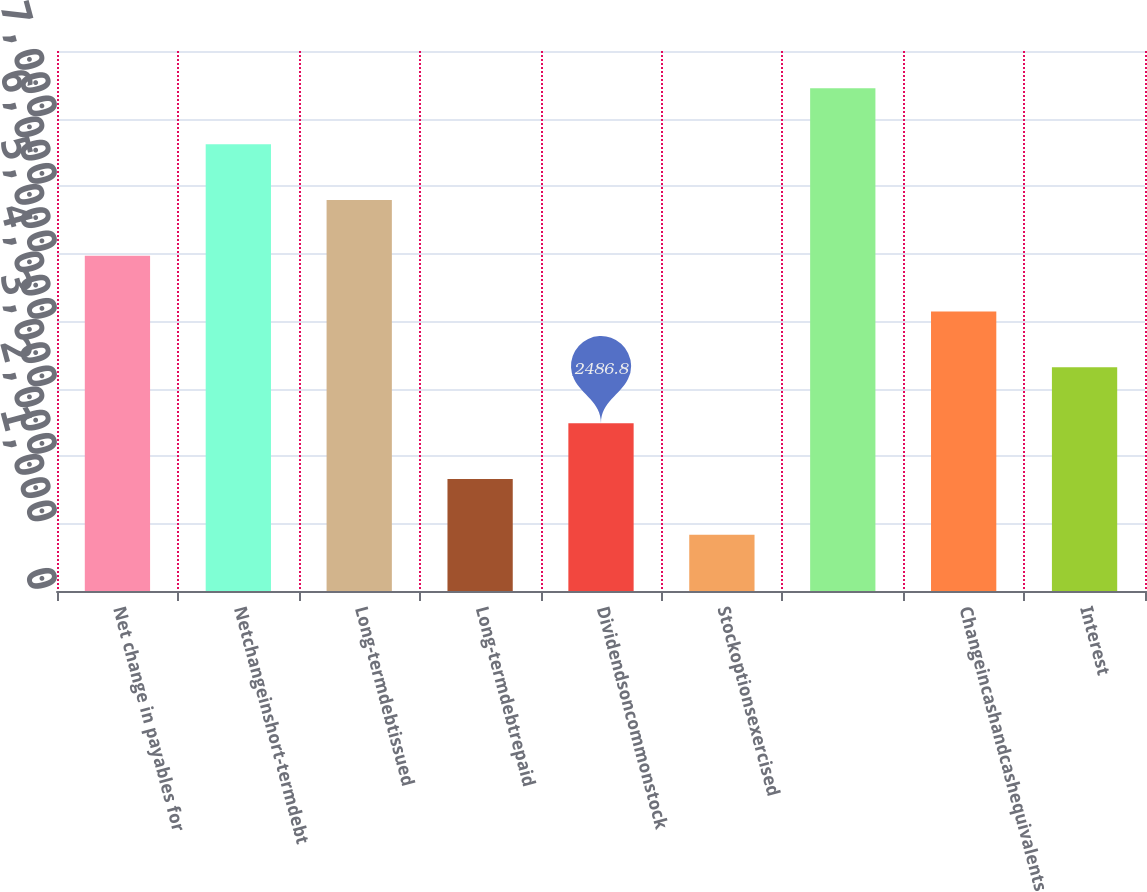Convert chart. <chart><loc_0><loc_0><loc_500><loc_500><bar_chart><fcel>Net change in payables for<fcel>Netchangeinshort-termdebt<fcel>Long-termdebtissued<fcel>Long-termdebtrepaid<fcel>Dividendsoncommonstock<fcel>Stockoptionsexercised<fcel>Unnamed: 6<fcel>Changeincashandcashequivalents<fcel>Interest<nl><fcel>4966.6<fcel>6619.8<fcel>5793.2<fcel>1660.2<fcel>2486.8<fcel>833.6<fcel>7446.4<fcel>4140<fcel>3313.4<nl></chart> 